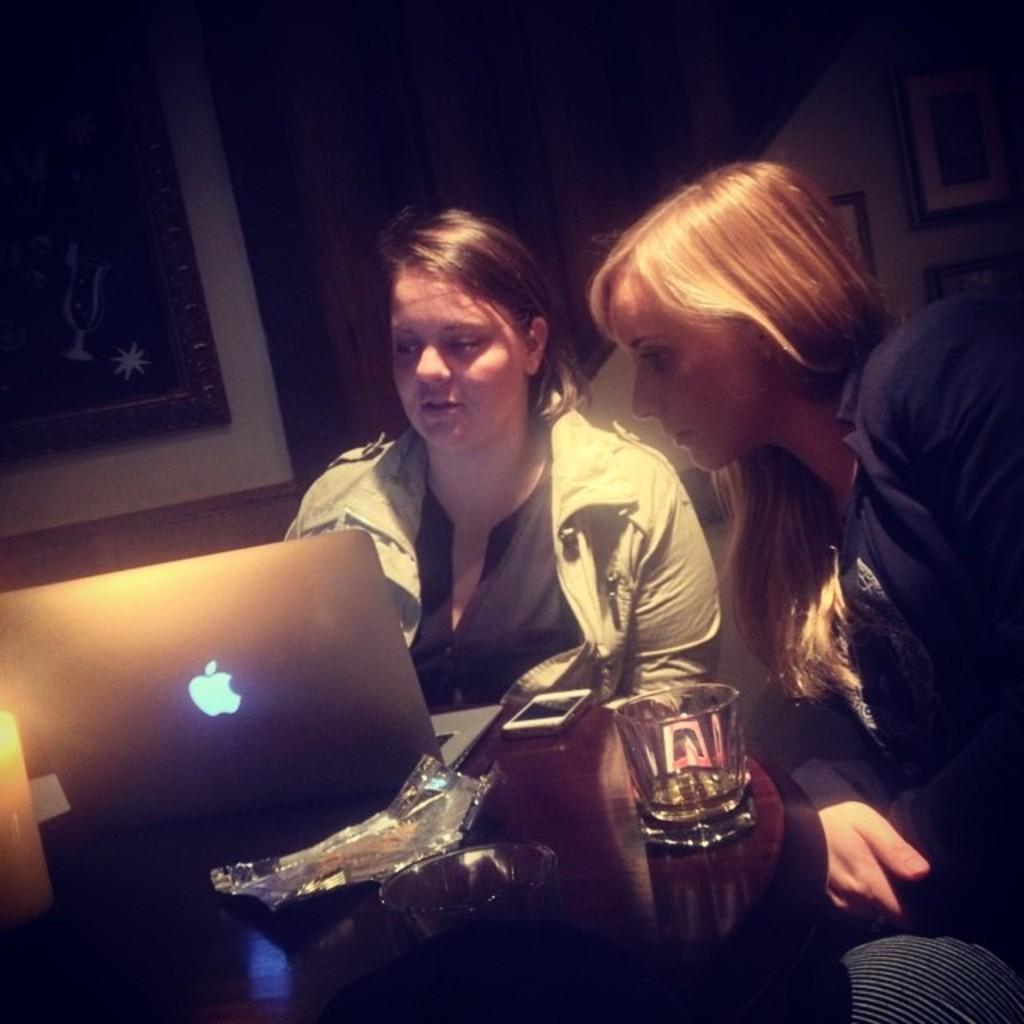How many girls are in the image? There are two girls in the image. What are the girls doing in the image? The girls are sitting on a chair. What is in front of the girls? There is a table in front of the girls. What objects can be seen on the table? There is a laptop, a phone, and a glass on the table. What is the lighting condition in the image? The background of the image is dark. What type of advertisement can be seen on the laptop screen in the image? There is no advertisement visible on the laptop screen in the image. How does the drain affect the girls in the image? There is no drain present in the image, so it does not affect the girls. 